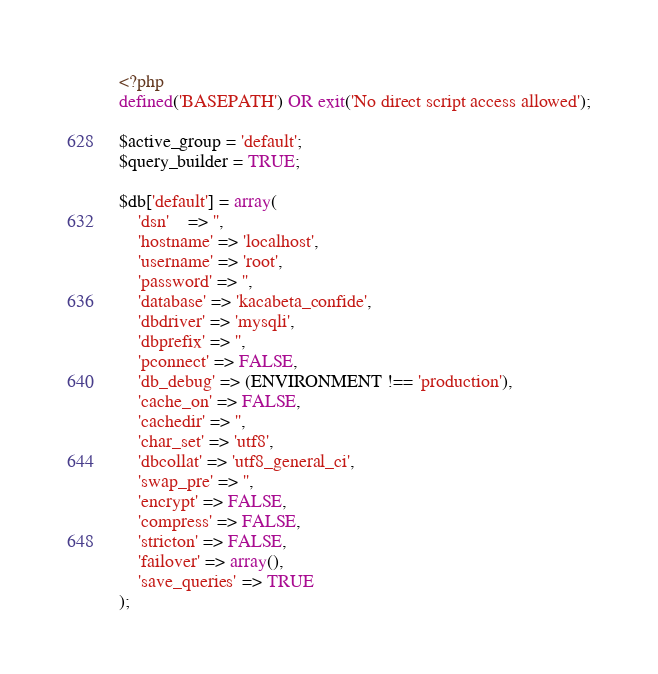Convert code to text. <code><loc_0><loc_0><loc_500><loc_500><_PHP_><?php
defined('BASEPATH') OR exit('No direct script access allowed');

$active_group = 'default';
$query_builder = TRUE;

$db['default'] = array(
	'dsn'	=> '',
	'hostname' => 'localhost',
	'username' => 'root',
	'password' => '',
	'database' => 'kacabeta_confide',
	'dbdriver' => 'mysqli',
	'dbprefix' => '',
	'pconnect' => FALSE,
	'db_debug' => (ENVIRONMENT !== 'production'),
	'cache_on' => FALSE,
	'cachedir' => '',
	'char_set' => 'utf8',
	'dbcollat' => 'utf8_general_ci',
	'swap_pre' => '',
	'encrypt' => FALSE,
	'compress' => FALSE,
	'stricton' => FALSE,
	'failover' => array(),
	'save_queries' => TRUE
);
</code> 